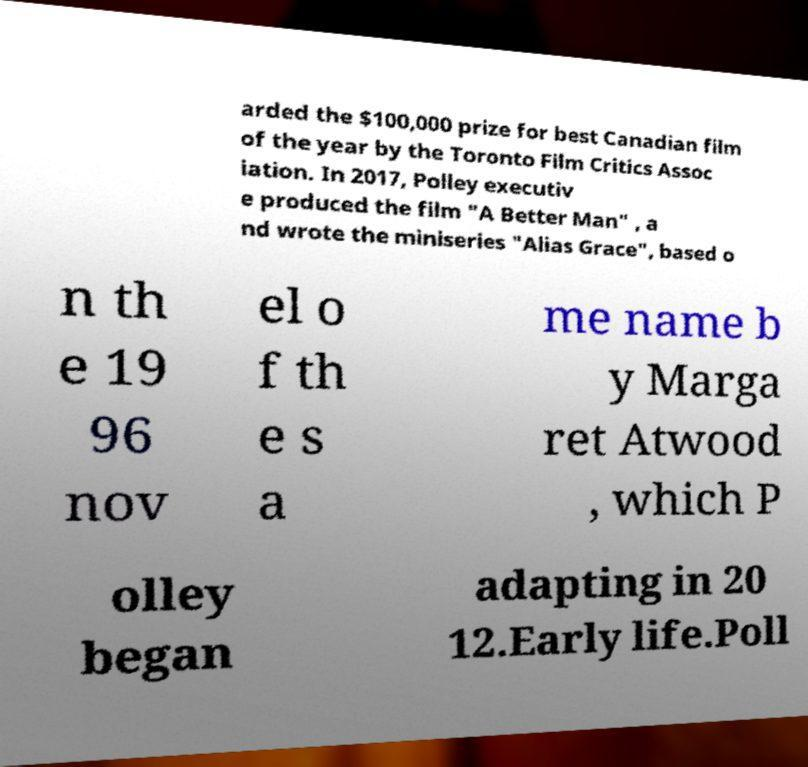Can you accurately transcribe the text from the provided image for me? arded the $100,000 prize for best Canadian film of the year by the Toronto Film Critics Assoc iation. In 2017, Polley executiv e produced the film "A Better Man" , a nd wrote the miniseries "Alias Grace", based o n th e 19 96 nov el o f th e s a me name b y Marga ret Atwood , which P olley began adapting in 20 12.Early life.Poll 